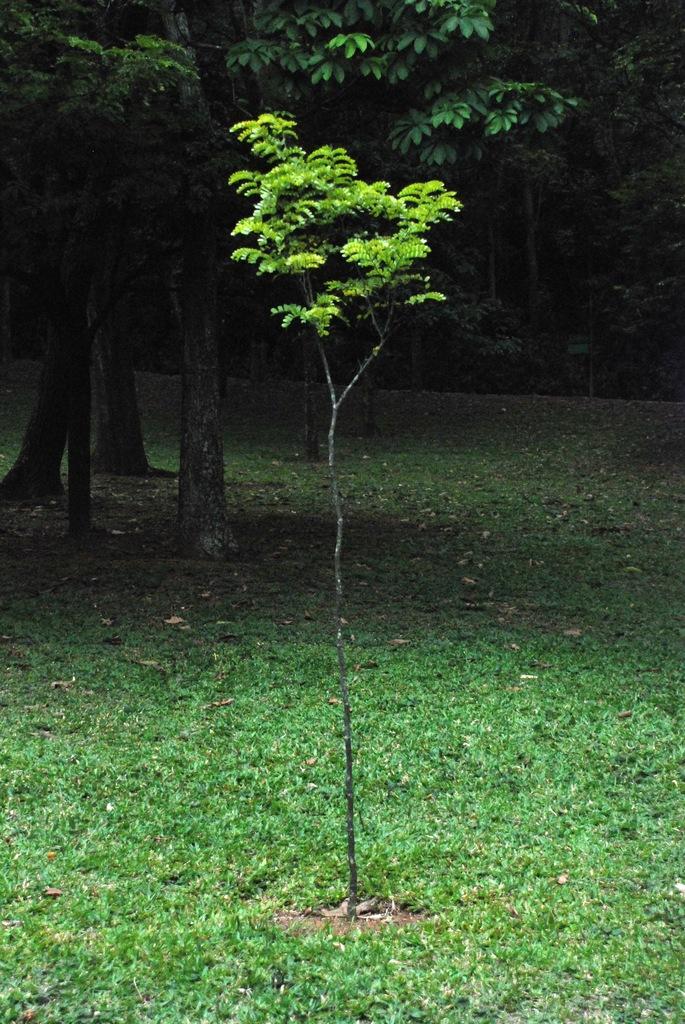Could you give a brief overview of what you see in this image? In this image we can trees, a plant, and the grass, also we can see some leaves on the ground. 